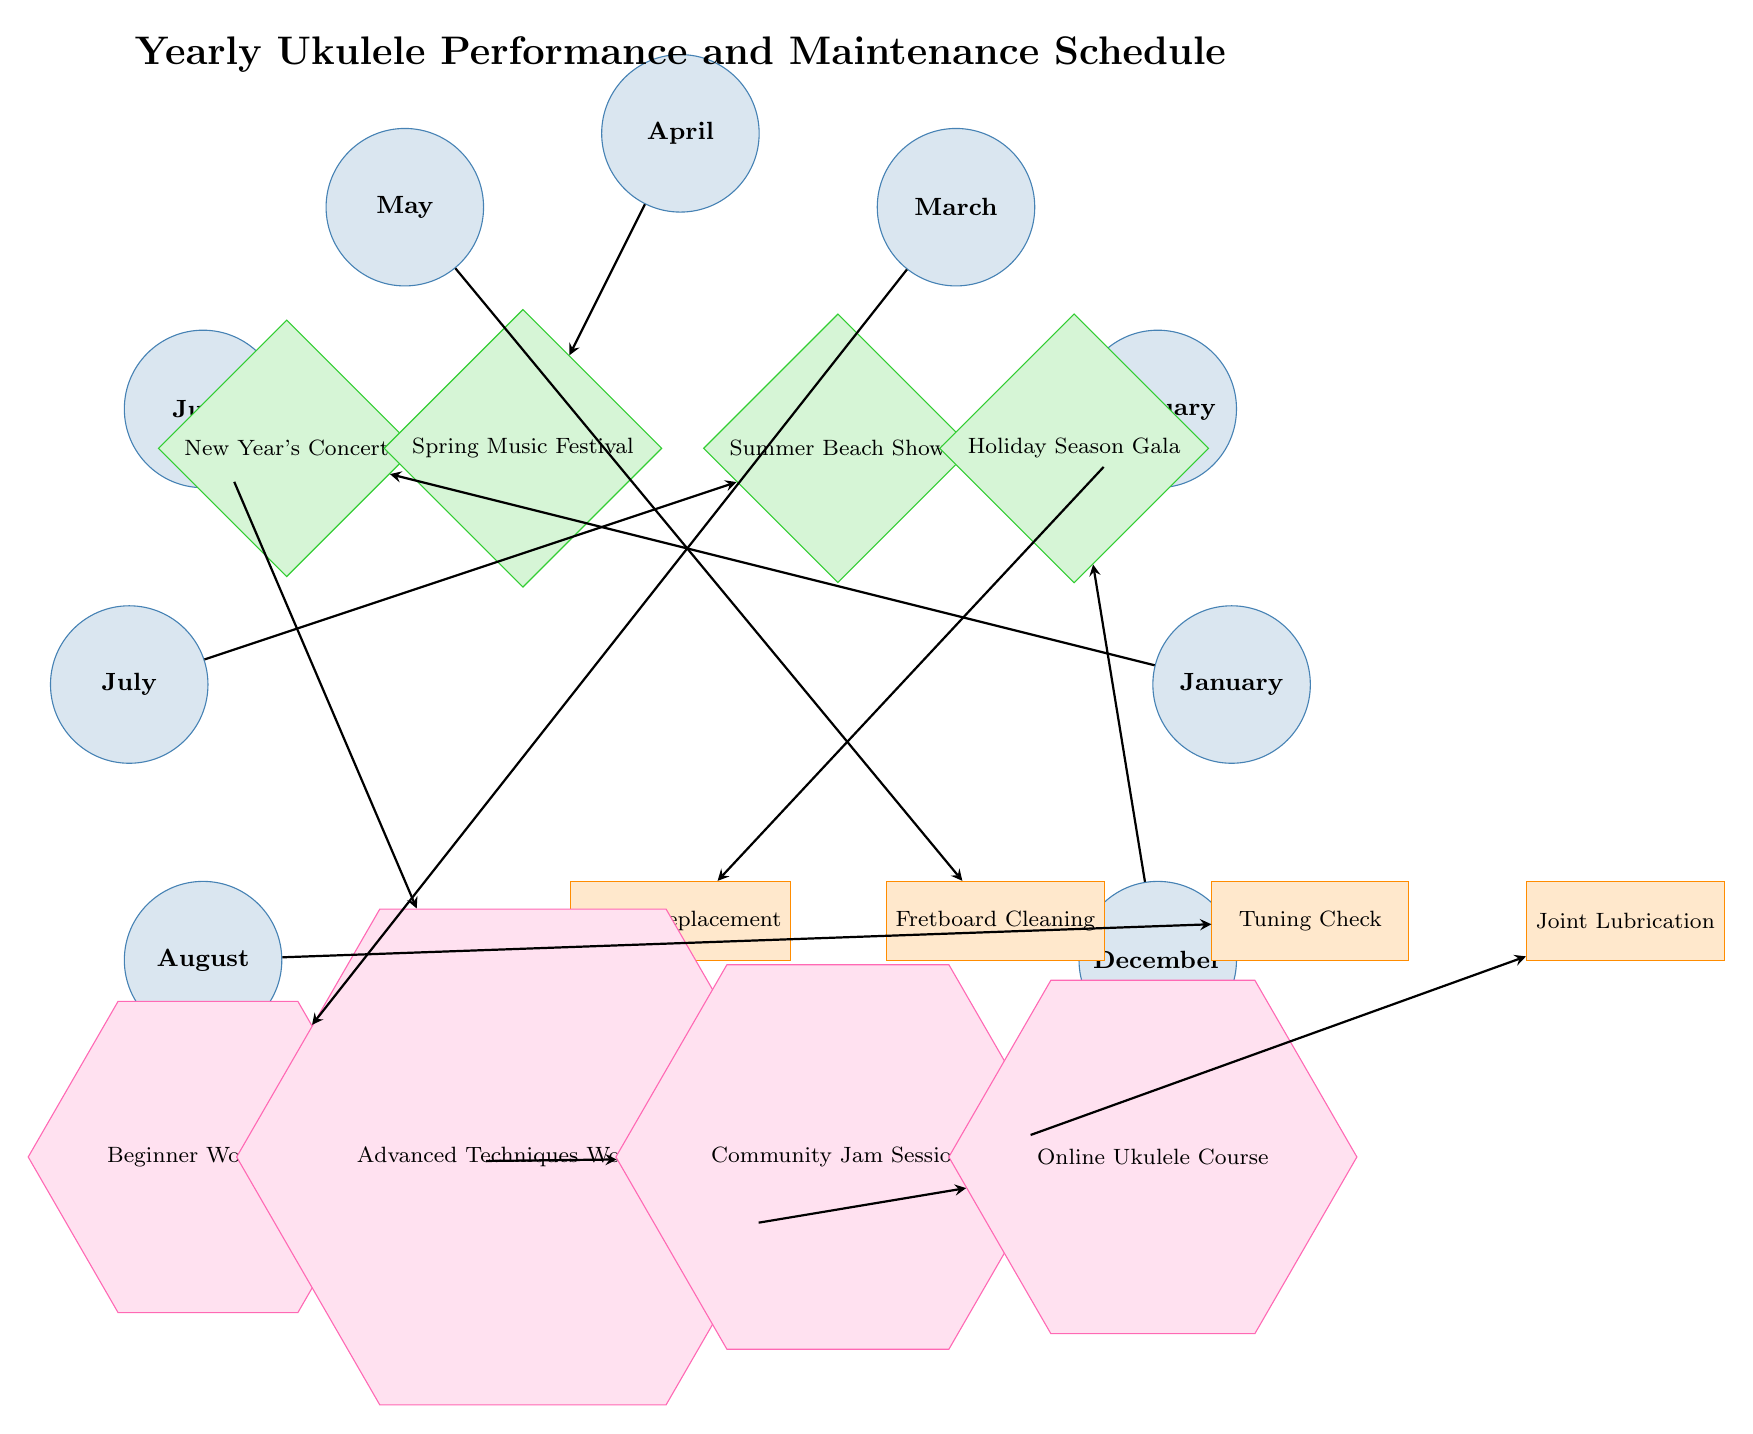What is the first performance listed in the diagram? The first performance is linked to the month of January, which shows "New Year's Concert" as the primary event.
Answer: New Year's Concert How many maintenance checks are included in the schedule? There are four maintenance checks listed: String Replacement, Fretboard Cleaning, Tuning Check, and Joint Lubrication, indicating a total of four items.
Answer: 4 In which month does the Fretboard Cleaning maintenance check occur? Fretboard Cleaning is connected to May, as indicated by the edges linking it to the corresponding month node.
Answer: May What type of shape represents workshops in the diagram? Workshops are represented by regular polygons with six sides, which is characteristic of hexagons, differentiating them visually from other types of events.
Answer: Hexagon Which performance is scheduled for August? The performance scheduled for August, as shown in the diagram, is the "Summer Beach Show," associated with the corresponding month node in the diagram.
Answer: Summer Beach Show Identify the month in which the Joint Lubrication maintenance check is scheduled. The Joint Lubrication check occurs in November; this association is made by following the edge from the month node to the maintenance node.
Answer: November What is the last workshop listed in the diagram? The last workshop is the "Online Ukulele Course," which is positioned at the end of the workshop listings based on the edge connections in the diagram.
Answer: Online Ukulele Course How many total performances are indicated in the schedule? The diagram shows four performance events scheduled throughout the year, which can be counted from the respective performance nodes linked to the months.
Answer: 4 Which month is associated with the Advanced Techniques Workshop? The Advanced Techniques Workshop is linked to June, shown through the edge that connects the month node to the workshop node.
Answer: June 